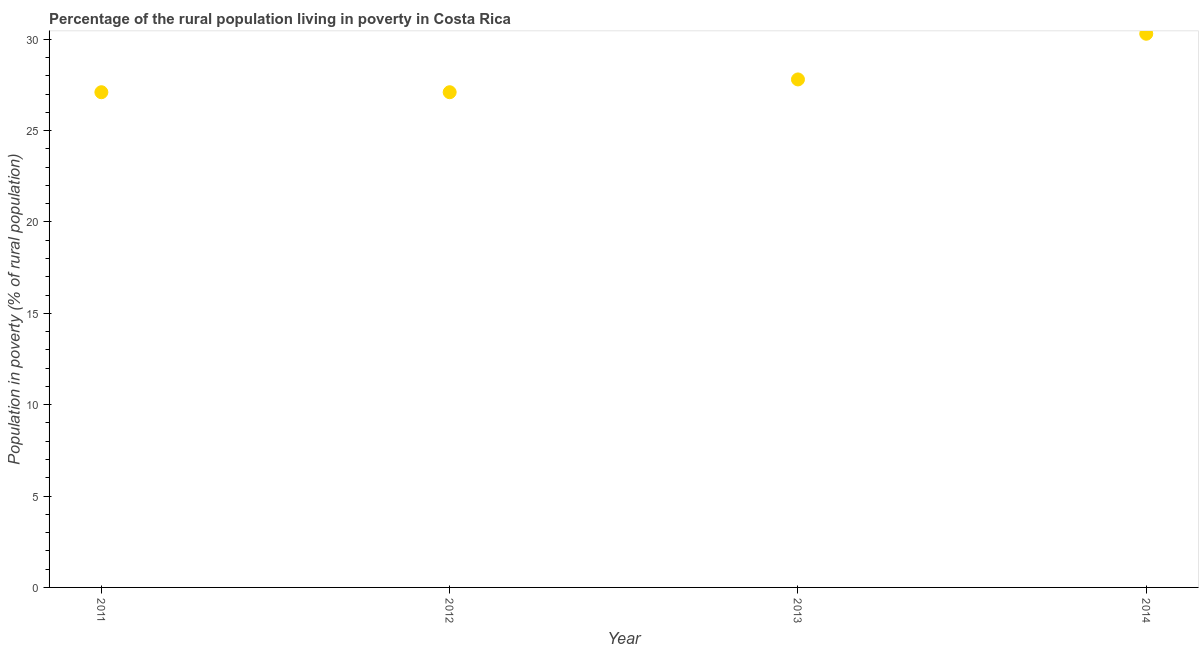What is the percentage of rural population living below poverty line in 2011?
Ensure brevity in your answer.  27.1. Across all years, what is the maximum percentage of rural population living below poverty line?
Ensure brevity in your answer.  30.3. Across all years, what is the minimum percentage of rural population living below poverty line?
Provide a short and direct response. 27.1. What is the sum of the percentage of rural population living below poverty line?
Make the answer very short. 112.3. What is the difference between the percentage of rural population living below poverty line in 2012 and 2014?
Provide a short and direct response. -3.2. What is the average percentage of rural population living below poverty line per year?
Make the answer very short. 28.07. What is the median percentage of rural population living below poverty line?
Make the answer very short. 27.45. Do a majority of the years between 2012 and 2014 (inclusive) have percentage of rural population living below poverty line greater than 26 %?
Keep it short and to the point. Yes. What is the ratio of the percentage of rural population living below poverty line in 2011 to that in 2013?
Your response must be concise. 0.97. Is the percentage of rural population living below poverty line in 2013 less than that in 2014?
Ensure brevity in your answer.  Yes. What is the difference between the highest and the lowest percentage of rural population living below poverty line?
Your answer should be very brief. 3.2. In how many years, is the percentage of rural population living below poverty line greater than the average percentage of rural population living below poverty line taken over all years?
Provide a short and direct response. 1. How many dotlines are there?
Give a very brief answer. 1. How many years are there in the graph?
Your response must be concise. 4. What is the difference between two consecutive major ticks on the Y-axis?
Provide a succinct answer. 5. Does the graph contain any zero values?
Offer a very short reply. No. Does the graph contain grids?
Give a very brief answer. No. What is the title of the graph?
Your answer should be compact. Percentage of the rural population living in poverty in Costa Rica. What is the label or title of the X-axis?
Make the answer very short. Year. What is the label or title of the Y-axis?
Provide a short and direct response. Population in poverty (% of rural population). What is the Population in poverty (% of rural population) in 2011?
Ensure brevity in your answer.  27.1. What is the Population in poverty (% of rural population) in 2012?
Provide a short and direct response. 27.1. What is the Population in poverty (% of rural population) in 2013?
Offer a very short reply. 27.8. What is the Population in poverty (% of rural population) in 2014?
Your answer should be compact. 30.3. What is the difference between the Population in poverty (% of rural population) in 2011 and 2012?
Your answer should be compact. 0. What is the difference between the Population in poverty (% of rural population) in 2011 and 2013?
Your response must be concise. -0.7. What is the difference between the Population in poverty (% of rural population) in 2012 and 2014?
Your answer should be compact. -3.2. What is the ratio of the Population in poverty (% of rural population) in 2011 to that in 2012?
Offer a very short reply. 1. What is the ratio of the Population in poverty (% of rural population) in 2011 to that in 2014?
Offer a very short reply. 0.89. What is the ratio of the Population in poverty (% of rural population) in 2012 to that in 2013?
Provide a short and direct response. 0.97. What is the ratio of the Population in poverty (% of rural population) in 2012 to that in 2014?
Make the answer very short. 0.89. What is the ratio of the Population in poverty (% of rural population) in 2013 to that in 2014?
Your answer should be compact. 0.92. 